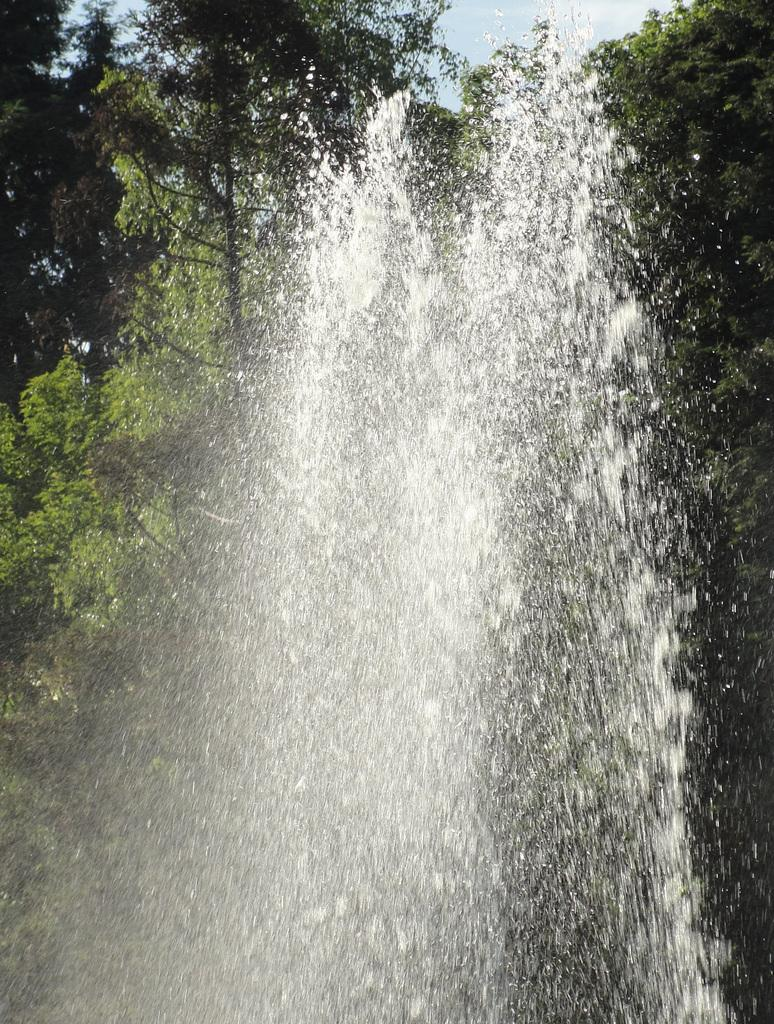What is visible in the foreground of the image? There is water in the foreground of the image. What can be seen in the background of the image? There are trees in the background of the image. What is the weather like in the image? The weather is sunny. What is the title of the book being read by the person in the image? There is no person or book present in the image, so it is not possible to determine the title of a book. 